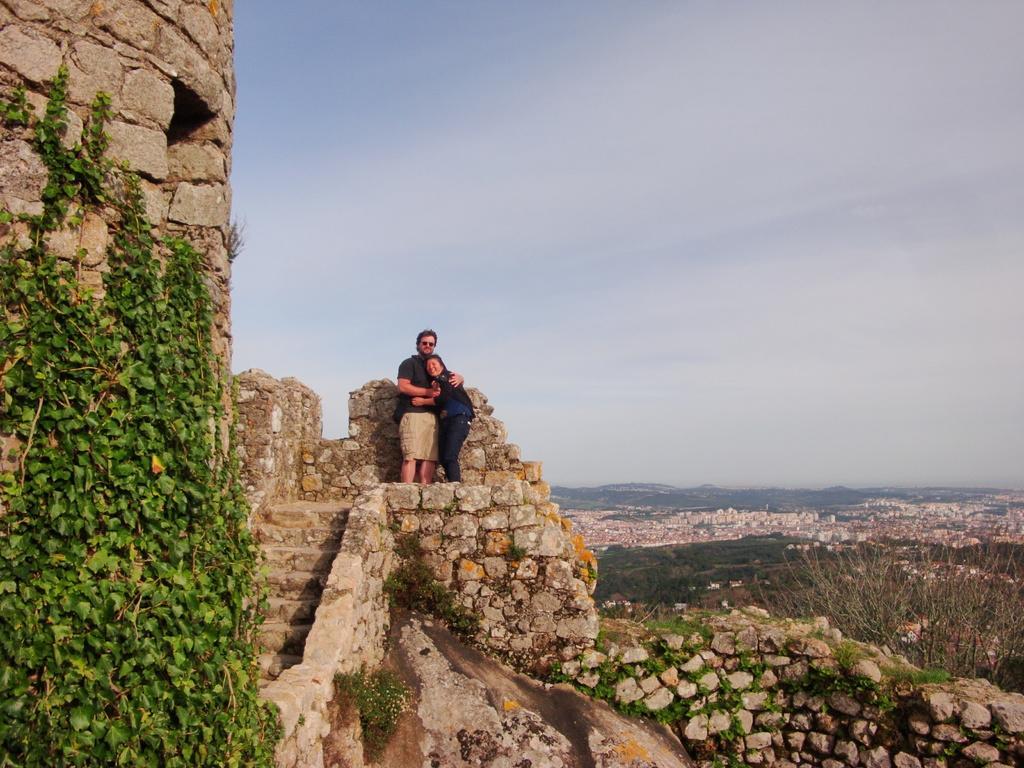In one or two sentences, can you explain what this image depicts? In this picture I can see there are two people standing here on the fort and there is a plant and the sky is clear. 